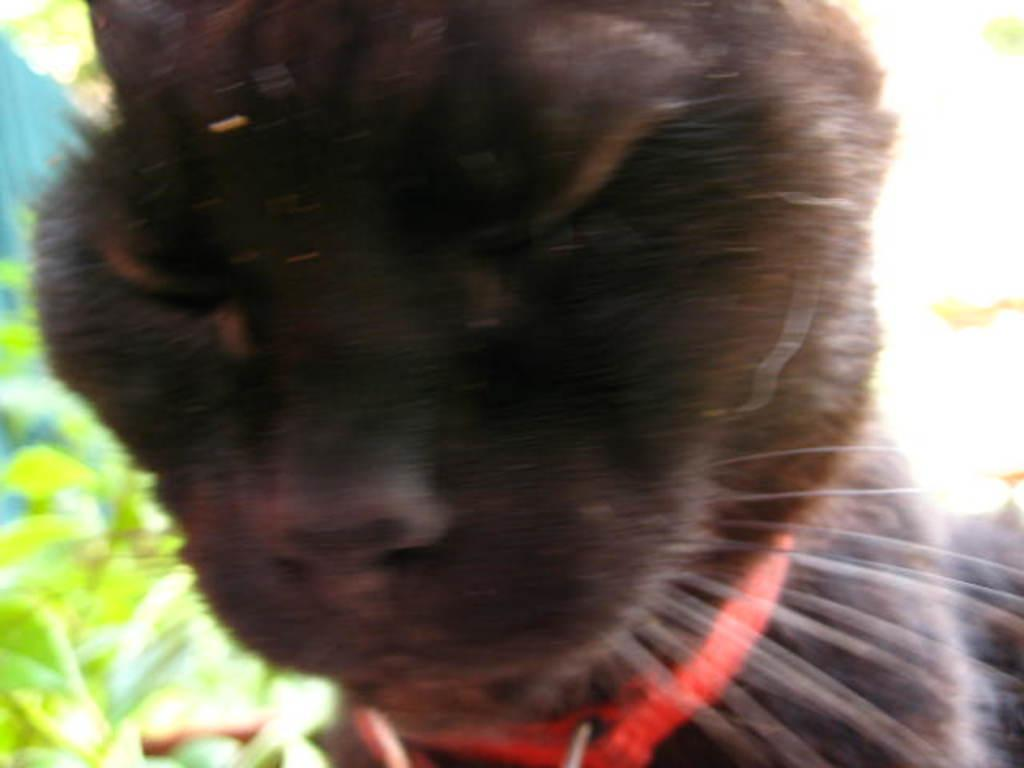What type of animal is in the image? There is a cat in the image. What color is the cat? The cat is black in color. Is there anything around the cat's neck? Yes, the cat has a red collar around its neck. What can be seen in the background of the image? The background of the image is white. Are there any natural elements visible in the image? Yes, there are leaves visible in the image. What type of wax can be seen melting on the dock in the image? There is no wax or dock present in the image; it features a black cat with a red collar against a white background. 